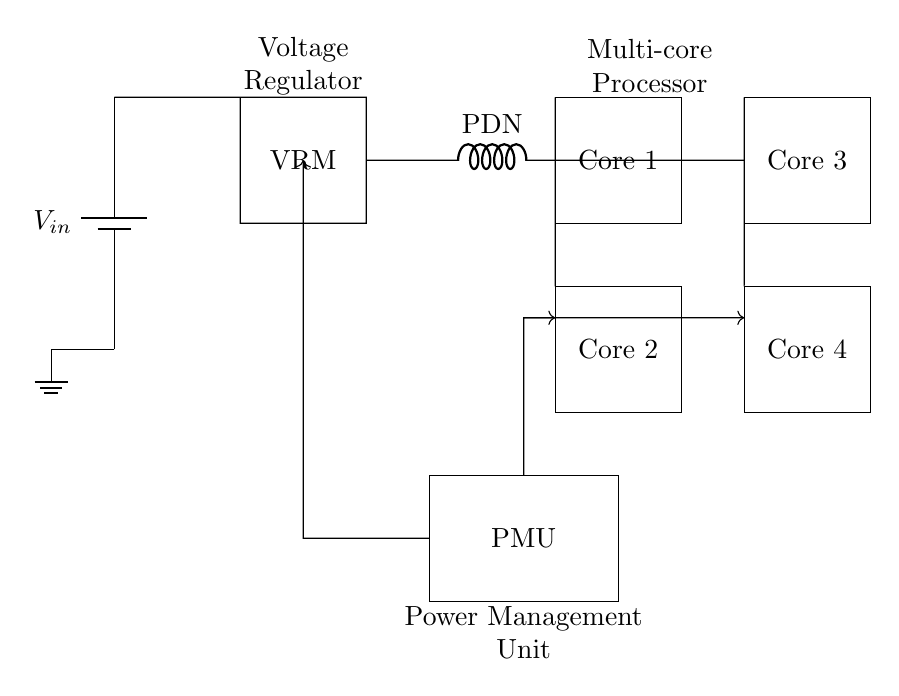What is the type of power supply used in the circuit? The circuit uses a battery as the power supply, indicated by the symbol labeled V in the top left.
Answer: battery How many cores are present in the circuit? The circuit diagram shows four rectangular nodes labeled as Core 1, Core 2, Core 3, and Core 4 respectively.
Answer: four What component regulates the voltage in this circuit? The component labeled VRM, which stands for Voltage Regulator Module, is responsible for regulating the voltage in the circuit.
Answer: VRM How is power distributed to the cores? Power is distributed to the cores through the Power Distribution Network (PDN), which is shown as an inductor labeled PDN connected to the cores.
Answer: PDN What is the role of the Power Management Unit? The Power Management Unit (PMU) is responsible for managing and controlling power distribution and may include functionalities such as voltage regulation and power sequencing.
Answer: PMU What type of circuit is this focused on? This circuit is focused on an efficient power management circuit, specifically designed for multi-core mobile processors.
Answer: efficient power management circuit What is the purpose of the control signals in this circuit? The control signals serve to manage operations between the PMU and the cores, ensuring proper voltage and power distribution as needed.
Answer: manage operations 